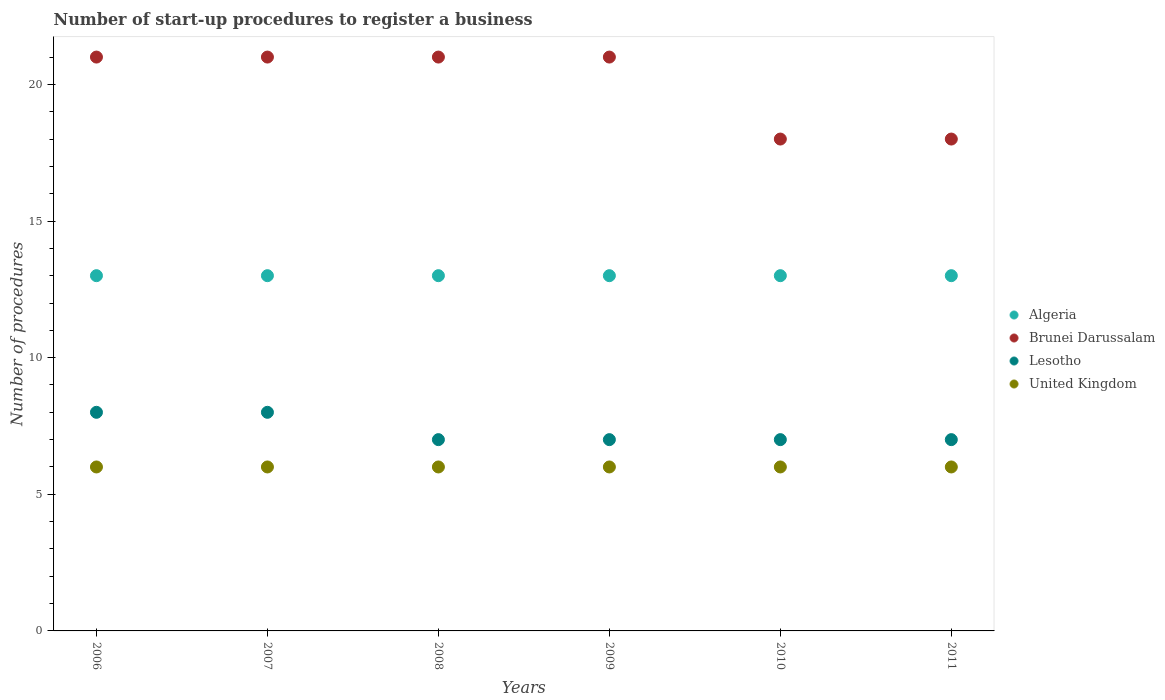How many different coloured dotlines are there?
Provide a succinct answer. 4. What is the number of procedures required to register a business in Lesotho in 2008?
Ensure brevity in your answer.  7. Across all years, what is the maximum number of procedures required to register a business in United Kingdom?
Ensure brevity in your answer.  6. Across all years, what is the minimum number of procedures required to register a business in Lesotho?
Keep it short and to the point. 7. In which year was the number of procedures required to register a business in United Kingdom minimum?
Keep it short and to the point. 2006. What is the total number of procedures required to register a business in Brunei Darussalam in the graph?
Offer a terse response. 120. What is the difference between the number of procedures required to register a business in Brunei Darussalam in 2006 and that in 2008?
Offer a terse response. 0. What is the average number of procedures required to register a business in Lesotho per year?
Your answer should be compact. 7.33. In how many years, is the number of procedures required to register a business in Algeria greater than 3?
Your response must be concise. 6. What is the difference between the highest and the lowest number of procedures required to register a business in Lesotho?
Provide a short and direct response. 1. Is it the case that in every year, the sum of the number of procedures required to register a business in Algeria and number of procedures required to register a business in Lesotho  is greater than the number of procedures required to register a business in Brunei Darussalam?
Provide a short and direct response. No. Does the number of procedures required to register a business in Brunei Darussalam monotonically increase over the years?
Ensure brevity in your answer.  No. Is the number of procedures required to register a business in Brunei Darussalam strictly less than the number of procedures required to register a business in Algeria over the years?
Provide a succinct answer. No. How many dotlines are there?
Provide a succinct answer. 4. What is the difference between two consecutive major ticks on the Y-axis?
Provide a succinct answer. 5. Does the graph contain any zero values?
Make the answer very short. No. Does the graph contain grids?
Offer a very short reply. No. Where does the legend appear in the graph?
Provide a succinct answer. Center right. How many legend labels are there?
Your answer should be very brief. 4. How are the legend labels stacked?
Your answer should be very brief. Vertical. What is the title of the graph?
Offer a very short reply. Number of start-up procedures to register a business. Does "Kuwait" appear as one of the legend labels in the graph?
Provide a short and direct response. No. What is the label or title of the X-axis?
Offer a terse response. Years. What is the label or title of the Y-axis?
Make the answer very short. Number of procedures. What is the Number of procedures in Brunei Darussalam in 2006?
Keep it short and to the point. 21. What is the Number of procedures of Lesotho in 2006?
Provide a succinct answer. 8. What is the Number of procedures in United Kingdom in 2006?
Your answer should be very brief. 6. What is the Number of procedures of Lesotho in 2007?
Your response must be concise. 8. What is the Number of procedures in Algeria in 2008?
Your answer should be very brief. 13. What is the Number of procedures of Brunei Darussalam in 2008?
Your answer should be compact. 21. What is the Number of procedures in Lesotho in 2008?
Offer a very short reply. 7. What is the Number of procedures in Brunei Darussalam in 2009?
Offer a terse response. 21. What is the Number of procedures in Algeria in 2010?
Your answer should be very brief. 13. What is the Number of procedures in Brunei Darussalam in 2010?
Offer a very short reply. 18. What is the Number of procedures in Lesotho in 2010?
Your answer should be compact. 7. What is the Number of procedures in United Kingdom in 2010?
Keep it short and to the point. 6. What is the Number of procedures in Algeria in 2011?
Your response must be concise. 13. What is the Number of procedures in Lesotho in 2011?
Your answer should be very brief. 7. Across all years, what is the maximum Number of procedures of Algeria?
Make the answer very short. 13. Across all years, what is the maximum Number of procedures in Brunei Darussalam?
Offer a terse response. 21. Across all years, what is the maximum Number of procedures of Lesotho?
Provide a short and direct response. 8. Across all years, what is the maximum Number of procedures in United Kingdom?
Offer a very short reply. 6. Across all years, what is the minimum Number of procedures of Algeria?
Make the answer very short. 13. Across all years, what is the minimum Number of procedures of Brunei Darussalam?
Provide a short and direct response. 18. Across all years, what is the minimum Number of procedures of United Kingdom?
Your answer should be compact. 6. What is the total Number of procedures of Algeria in the graph?
Offer a terse response. 78. What is the total Number of procedures of Brunei Darussalam in the graph?
Your answer should be very brief. 120. What is the total Number of procedures in Lesotho in the graph?
Your answer should be compact. 44. What is the total Number of procedures in United Kingdom in the graph?
Make the answer very short. 36. What is the difference between the Number of procedures in Algeria in 2006 and that in 2007?
Provide a succinct answer. 0. What is the difference between the Number of procedures in Brunei Darussalam in 2006 and that in 2007?
Provide a succinct answer. 0. What is the difference between the Number of procedures in Lesotho in 2006 and that in 2007?
Offer a very short reply. 0. What is the difference between the Number of procedures of Brunei Darussalam in 2006 and that in 2008?
Your response must be concise. 0. What is the difference between the Number of procedures of Lesotho in 2006 and that in 2008?
Give a very brief answer. 1. What is the difference between the Number of procedures in United Kingdom in 2006 and that in 2008?
Keep it short and to the point. 0. What is the difference between the Number of procedures of Algeria in 2006 and that in 2009?
Ensure brevity in your answer.  0. What is the difference between the Number of procedures in United Kingdom in 2006 and that in 2009?
Your answer should be compact. 0. What is the difference between the Number of procedures in Brunei Darussalam in 2006 and that in 2010?
Your response must be concise. 3. What is the difference between the Number of procedures in United Kingdom in 2006 and that in 2010?
Ensure brevity in your answer.  0. What is the difference between the Number of procedures of United Kingdom in 2006 and that in 2011?
Your response must be concise. 0. What is the difference between the Number of procedures of Brunei Darussalam in 2007 and that in 2008?
Provide a short and direct response. 0. What is the difference between the Number of procedures in United Kingdom in 2007 and that in 2008?
Your answer should be very brief. 0. What is the difference between the Number of procedures of Algeria in 2007 and that in 2009?
Your answer should be very brief. 0. What is the difference between the Number of procedures in United Kingdom in 2007 and that in 2009?
Make the answer very short. 0. What is the difference between the Number of procedures in Brunei Darussalam in 2007 and that in 2010?
Offer a terse response. 3. What is the difference between the Number of procedures of United Kingdom in 2007 and that in 2010?
Provide a succinct answer. 0. What is the difference between the Number of procedures of Brunei Darussalam in 2007 and that in 2011?
Give a very brief answer. 3. What is the difference between the Number of procedures of Lesotho in 2007 and that in 2011?
Your response must be concise. 1. What is the difference between the Number of procedures of United Kingdom in 2007 and that in 2011?
Keep it short and to the point. 0. What is the difference between the Number of procedures in Algeria in 2008 and that in 2009?
Your response must be concise. 0. What is the difference between the Number of procedures in Brunei Darussalam in 2008 and that in 2009?
Provide a short and direct response. 0. What is the difference between the Number of procedures of Algeria in 2008 and that in 2010?
Your response must be concise. 0. What is the difference between the Number of procedures of United Kingdom in 2008 and that in 2010?
Keep it short and to the point. 0. What is the difference between the Number of procedures of Algeria in 2008 and that in 2011?
Make the answer very short. 0. What is the difference between the Number of procedures of Brunei Darussalam in 2008 and that in 2011?
Make the answer very short. 3. What is the difference between the Number of procedures of Algeria in 2009 and that in 2010?
Give a very brief answer. 0. What is the difference between the Number of procedures of Brunei Darussalam in 2009 and that in 2011?
Provide a short and direct response. 3. What is the difference between the Number of procedures of United Kingdom in 2009 and that in 2011?
Keep it short and to the point. 0. What is the difference between the Number of procedures in Brunei Darussalam in 2010 and that in 2011?
Make the answer very short. 0. What is the difference between the Number of procedures of Lesotho in 2010 and that in 2011?
Your answer should be very brief. 0. What is the difference between the Number of procedures of Algeria in 2006 and the Number of procedures of Brunei Darussalam in 2007?
Ensure brevity in your answer.  -8. What is the difference between the Number of procedures in Brunei Darussalam in 2006 and the Number of procedures in United Kingdom in 2007?
Make the answer very short. 15. What is the difference between the Number of procedures in Lesotho in 2006 and the Number of procedures in United Kingdom in 2007?
Your answer should be very brief. 2. What is the difference between the Number of procedures of Algeria in 2006 and the Number of procedures of Brunei Darussalam in 2008?
Your answer should be very brief. -8. What is the difference between the Number of procedures in Algeria in 2006 and the Number of procedures in United Kingdom in 2008?
Provide a short and direct response. 7. What is the difference between the Number of procedures of Algeria in 2006 and the Number of procedures of United Kingdom in 2009?
Offer a terse response. 7. What is the difference between the Number of procedures of Brunei Darussalam in 2006 and the Number of procedures of Lesotho in 2009?
Offer a very short reply. 14. What is the difference between the Number of procedures in Lesotho in 2006 and the Number of procedures in United Kingdom in 2009?
Your answer should be very brief. 2. What is the difference between the Number of procedures in Brunei Darussalam in 2006 and the Number of procedures in Lesotho in 2010?
Keep it short and to the point. 14. What is the difference between the Number of procedures of Algeria in 2006 and the Number of procedures of Brunei Darussalam in 2011?
Provide a succinct answer. -5. What is the difference between the Number of procedures in Brunei Darussalam in 2006 and the Number of procedures in Lesotho in 2011?
Provide a succinct answer. 14. What is the difference between the Number of procedures of Brunei Darussalam in 2006 and the Number of procedures of United Kingdom in 2011?
Provide a succinct answer. 15. What is the difference between the Number of procedures in Lesotho in 2006 and the Number of procedures in United Kingdom in 2011?
Offer a very short reply. 2. What is the difference between the Number of procedures in Algeria in 2007 and the Number of procedures in Lesotho in 2008?
Your answer should be compact. 6. What is the difference between the Number of procedures in Algeria in 2007 and the Number of procedures in United Kingdom in 2008?
Keep it short and to the point. 7. What is the difference between the Number of procedures in Lesotho in 2007 and the Number of procedures in United Kingdom in 2008?
Make the answer very short. 2. What is the difference between the Number of procedures in Algeria in 2007 and the Number of procedures in Brunei Darussalam in 2009?
Provide a short and direct response. -8. What is the difference between the Number of procedures in Algeria in 2007 and the Number of procedures in United Kingdom in 2009?
Provide a short and direct response. 7. What is the difference between the Number of procedures in Brunei Darussalam in 2007 and the Number of procedures in United Kingdom in 2009?
Ensure brevity in your answer.  15. What is the difference between the Number of procedures in Algeria in 2007 and the Number of procedures in Brunei Darussalam in 2010?
Make the answer very short. -5. What is the difference between the Number of procedures in Algeria in 2007 and the Number of procedures in United Kingdom in 2010?
Ensure brevity in your answer.  7. What is the difference between the Number of procedures of Lesotho in 2007 and the Number of procedures of United Kingdom in 2010?
Give a very brief answer. 2. What is the difference between the Number of procedures of Algeria in 2007 and the Number of procedures of Brunei Darussalam in 2011?
Your answer should be compact. -5. What is the difference between the Number of procedures of Algeria in 2008 and the Number of procedures of Brunei Darussalam in 2009?
Your answer should be compact. -8. What is the difference between the Number of procedures in Algeria in 2008 and the Number of procedures in United Kingdom in 2009?
Your response must be concise. 7. What is the difference between the Number of procedures of Lesotho in 2008 and the Number of procedures of United Kingdom in 2009?
Offer a very short reply. 1. What is the difference between the Number of procedures of Algeria in 2008 and the Number of procedures of Lesotho in 2010?
Ensure brevity in your answer.  6. What is the difference between the Number of procedures in Brunei Darussalam in 2008 and the Number of procedures in United Kingdom in 2010?
Give a very brief answer. 15. What is the difference between the Number of procedures of Lesotho in 2008 and the Number of procedures of United Kingdom in 2010?
Provide a short and direct response. 1. What is the difference between the Number of procedures of Algeria in 2008 and the Number of procedures of United Kingdom in 2011?
Provide a short and direct response. 7. What is the difference between the Number of procedures of Brunei Darussalam in 2008 and the Number of procedures of United Kingdom in 2011?
Provide a succinct answer. 15. What is the difference between the Number of procedures in Algeria in 2009 and the Number of procedures in United Kingdom in 2010?
Ensure brevity in your answer.  7. What is the difference between the Number of procedures of Algeria in 2009 and the Number of procedures of Brunei Darussalam in 2011?
Offer a very short reply. -5. What is the difference between the Number of procedures of Algeria in 2009 and the Number of procedures of United Kingdom in 2011?
Your answer should be very brief. 7. What is the difference between the Number of procedures in Brunei Darussalam in 2009 and the Number of procedures in United Kingdom in 2011?
Make the answer very short. 15. What is the difference between the Number of procedures of Algeria in 2010 and the Number of procedures of Brunei Darussalam in 2011?
Provide a short and direct response. -5. What is the difference between the Number of procedures of Algeria in 2010 and the Number of procedures of United Kingdom in 2011?
Your answer should be very brief. 7. What is the average Number of procedures of Algeria per year?
Provide a succinct answer. 13. What is the average Number of procedures of Brunei Darussalam per year?
Your response must be concise. 20. What is the average Number of procedures of Lesotho per year?
Offer a very short reply. 7.33. In the year 2006, what is the difference between the Number of procedures of Algeria and Number of procedures of Brunei Darussalam?
Offer a terse response. -8. In the year 2006, what is the difference between the Number of procedures of Brunei Darussalam and Number of procedures of Lesotho?
Your response must be concise. 13. In the year 2006, what is the difference between the Number of procedures in Brunei Darussalam and Number of procedures in United Kingdom?
Give a very brief answer. 15. In the year 2007, what is the difference between the Number of procedures of Algeria and Number of procedures of Brunei Darussalam?
Provide a succinct answer. -8. In the year 2007, what is the difference between the Number of procedures of Algeria and Number of procedures of United Kingdom?
Your answer should be very brief. 7. In the year 2008, what is the difference between the Number of procedures of Algeria and Number of procedures of Brunei Darussalam?
Your answer should be compact. -8. In the year 2009, what is the difference between the Number of procedures of Algeria and Number of procedures of United Kingdom?
Your response must be concise. 7. In the year 2009, what is the difference between the Number of procedures in Lesotho and Number of procedures in United Kingdom?
Provide a short and direct response. 1. In the year 2010, what is the difference between the Number of procedures of Algeria and Number of procedures of Brunei Darussalam?
Offer a very short reply. -5. In the year 2010, what is the difference between the Number of procedures of Algeria and Number of procedures of Lesotho?
Keep it short and to the point. 6. In the year 2010, what is the difference between the Number of procedures in Brunei Darussalam and Number of procedures in Lesotho?
Give a very brief answer. 11. In the year 2011, what is the difference between the Number of procedures of Algeria and Number of procedures of Brunei Darussalam?
Keep it short and to the point. -5. In the year 2011, what is the difference between the Number of procedures in Algeria and Number of procedures in Lesotho?
Offer a terse response. 6. In the year 2011, what is the difference between the Number of procedures in Algeria and Number of procedures in United Kingdom?
Offer a terse response. 7. In the year 2011, what is the difference between the Number of procedures of Brunei Darussalam and Number of procedures of United Kingdom?
Make the answer very short. 12. In the year 2011, what is the difference between the Number of procedures in Lesotho and Number of procedures in United Kingdom?
Provide a succinct answer. 1. What is the ratio of the Number of procedures of Brunei Darussalam in 2006 to that in 2007?
Offer a very short reply. 1. What is the ratio of the Number of procedures in Algeria in 2006 to that in 2008?
Keep it short and to the point. 1. What is the ratio of the Number of procedures in United Kingdom in 2006 to that in 2008?
Offer a terse response. 1. What is the ratio of the Number of procedures of Algeria in 2006 to that in 2009?
Ensure brevity in your answer.  1. What is the ratio of the Number of procedures in Brunei Darussalam in 2006 to that in 2009?
Provide a succinct answer. 1. What is the ratio of the Number of procedures in Algeria in 2006 to that in 2011?
Provide a short and direct response. 1. What is the ratio of the Number of procedures of Algeria in 2007 to that in 2008?
Your answer should be very brief. 1. What is the ratio of the Number of procedures in Lesotho in 2007 to that in 2008?
Keep it short and to the point. 1.14. What is the ratio of the Number of procedures in Algeria in 2007 to that in 2009?
Provide a short and direct response. 1. What is the ratio of the Number of procedures in Brunei Darussalam in 2007 to that in 2009?
Keep it short and to the point. 1. What is the ratio of the Number of procedures of Lesotho in 2007 to that in 2009?
Offer a very short reply. 1.14. What is the ratio of the Number of procedures in Algeria in 2007 to that in 2011?
Ensure brevity in your answer.  1. What is the ratio of the Number of procedures of Brunei Darussalam in 2007 to that in 2011?
Keep it short and to the point. 1.17. What is the ratio of the Number of procedures of United Kingdom in 2007 to that in 2011?
Your answer should be very brief. 1. What is the ratio of the Number of procedures of Algeria in 2008 to that in 2009?
Provide a short and direct response. 1. What is the ratio of the Number of procedures in Brunei Darussalam in 2008 to that in 2009?
Keep it short and to the point. 1. What is the ratio of the Number of procedures in Lesotho in 2008 to that in 2009?
Ensure brevity in your answer.  1. What is the ratio of the Number of procedures in Algeria in 2008 to that in 2010?
Give a very brief answer. 1. What is the ratio of the Number of procedures of Brunei Darussalam in 2008 to that in 2010?
Your answer should be compact. 1.17. What is the ratio of the Number of procedures of Lesotho in 2008 to that in 2010?
Your answer should be very brief. 1. What is the ratio of the Number of procedures in Algeria in 2008 to that in 2011?
Your response must be concise. 1. What is the ratio of the Number of procedures in Brunei Darussalam in 2008 to that in 2011?
Provide a succinct answer. 1.17. What is the ratio of the Number of procedures in United Kingdom in 2008 to that in 2011?
Ensure brevity in your answer.  1. What is the ratio of the Number of procedures of Brunei Darussalam in 2009 to that in 2010?
Keep it short and to the point. 1.17. What is the ratio of the Number of procedures in Algeria in 2009 to that in 2011?
Give a very brief answer. 1. What is the ratio of the Number of procedures of Brunei Darussalam in 2009 to that in 2011?
Offer a terse response. 1.17. What is the ratio of the Number of procedures of Lesotho in 2009 to that in 2011?
Provide a succinct answer. 1. What is the ratio of the Number of procedures in United Kingdom in 2009 to that in 2011?
Ensure brevity in your answer.  1. What is the ratio of the Number of procedures of Brunei Darussalam in 2010 to that in 2011?
Make the answer very short. 1. What is the ratio of the Number of procedures of Lesotho in 2010 to that in 2011?
Your answer should be compact. 1. What is the difference between the highest and the second highest Number of procedures in Algeria?
Make the answer very short. 0. What is the difference between the highest and the second highest Number of procedures in United Kingdom?
Your answer should be compact. 0. What is the difference between the highest and the lowest Number of procedures of Algeria?
Make the answer very short. 0. What is the difference between the highest and the lowest Number of procedures of Lesotho?
Offer a terse response. 1. 